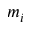Convert formula to latex. <formula><loc_0><loc_0><loc_500><loc_500>m _ { i }</formula> 